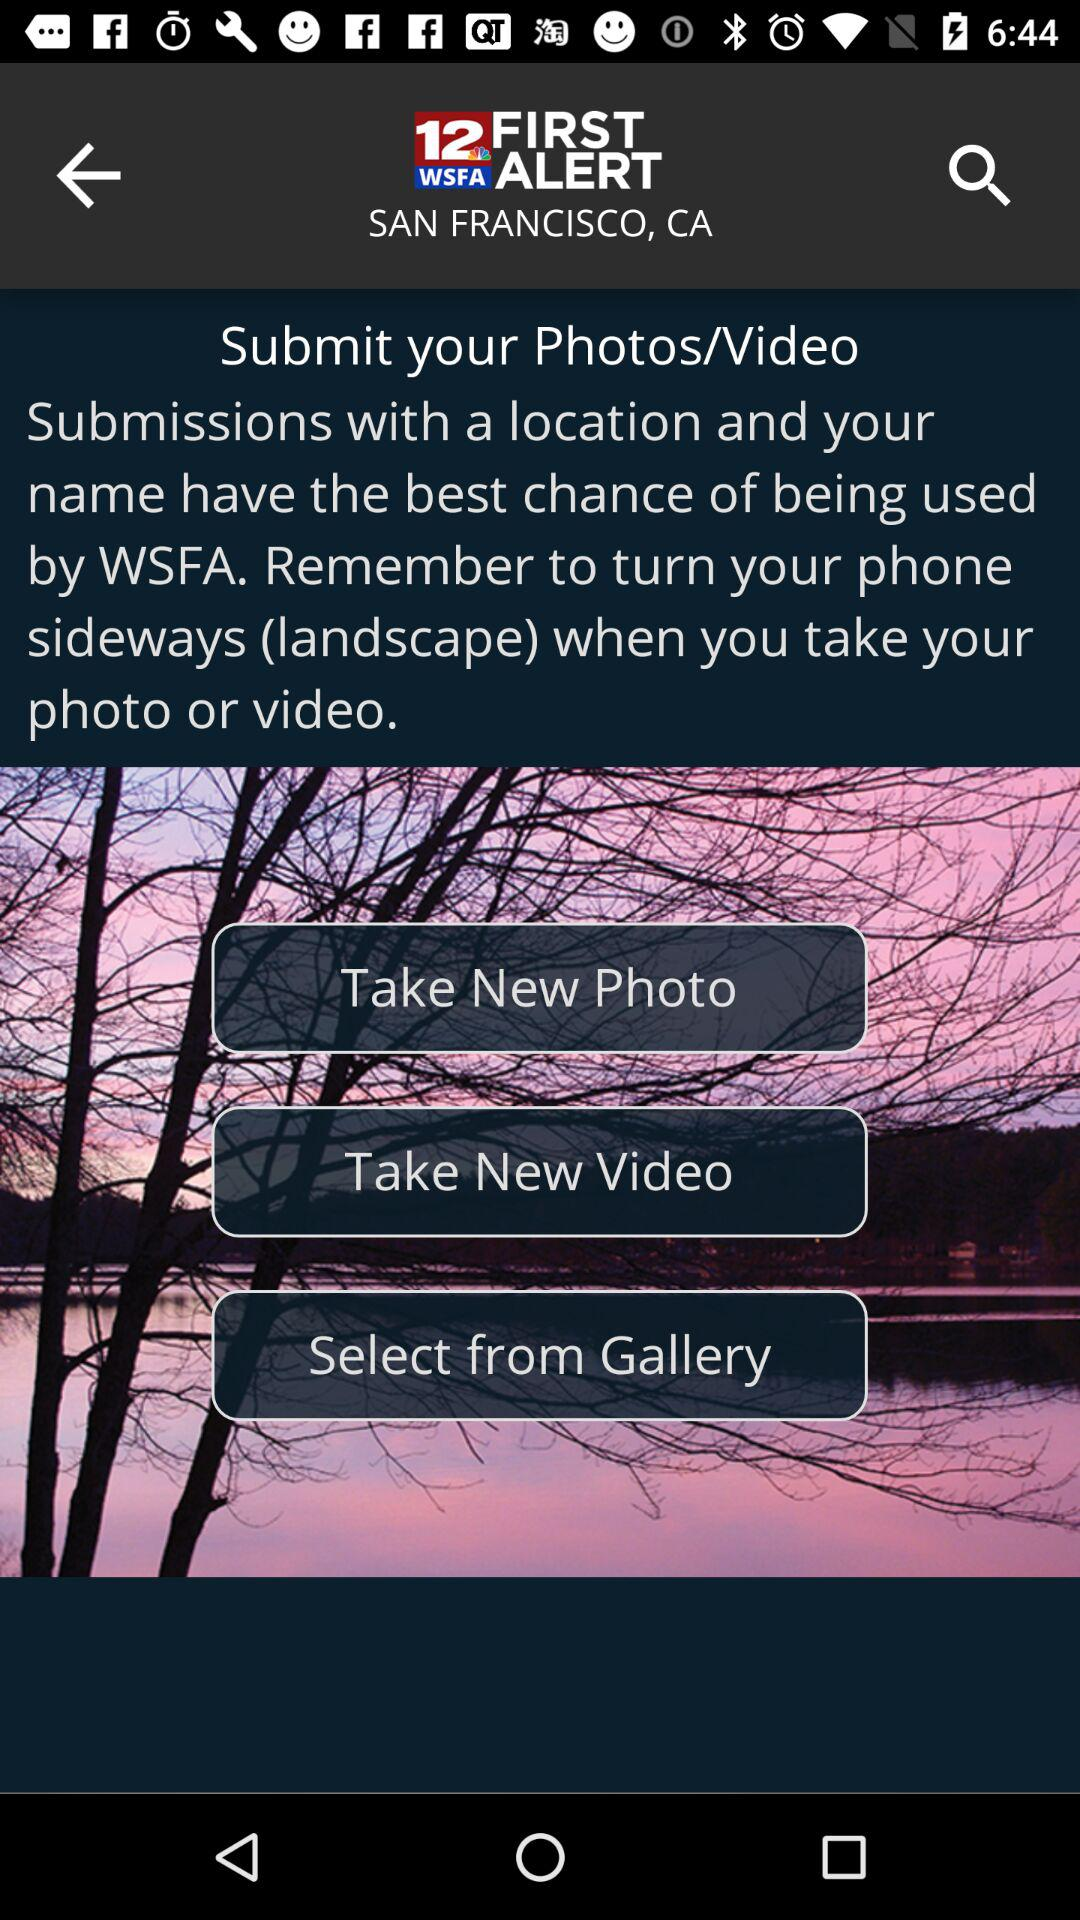What is the location? The location is San Francisco, CA. 